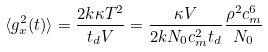<formula> <loc_0><loc_0><loc_500><loc_500>\langle g ^ { 2 } _ { x } ( t ) \rangle = \frac { 2 k \kappa T ^ { 2 } } { t _ { d } V } = \frac { \kappa V } { 2 k N _ { 0 } c _ { m } ^ { 2 } t _ { d } } \frac { \rho ^ { 2 } c _ { m } ^ { 6 } } { N _ { 0 } }</formula> 